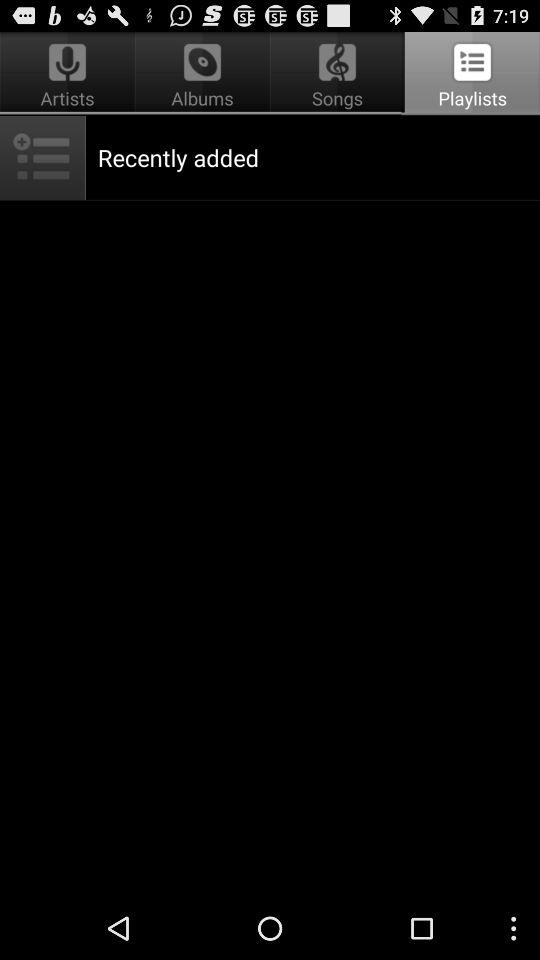Which tab is selected? The selected tab is "Playlists". 